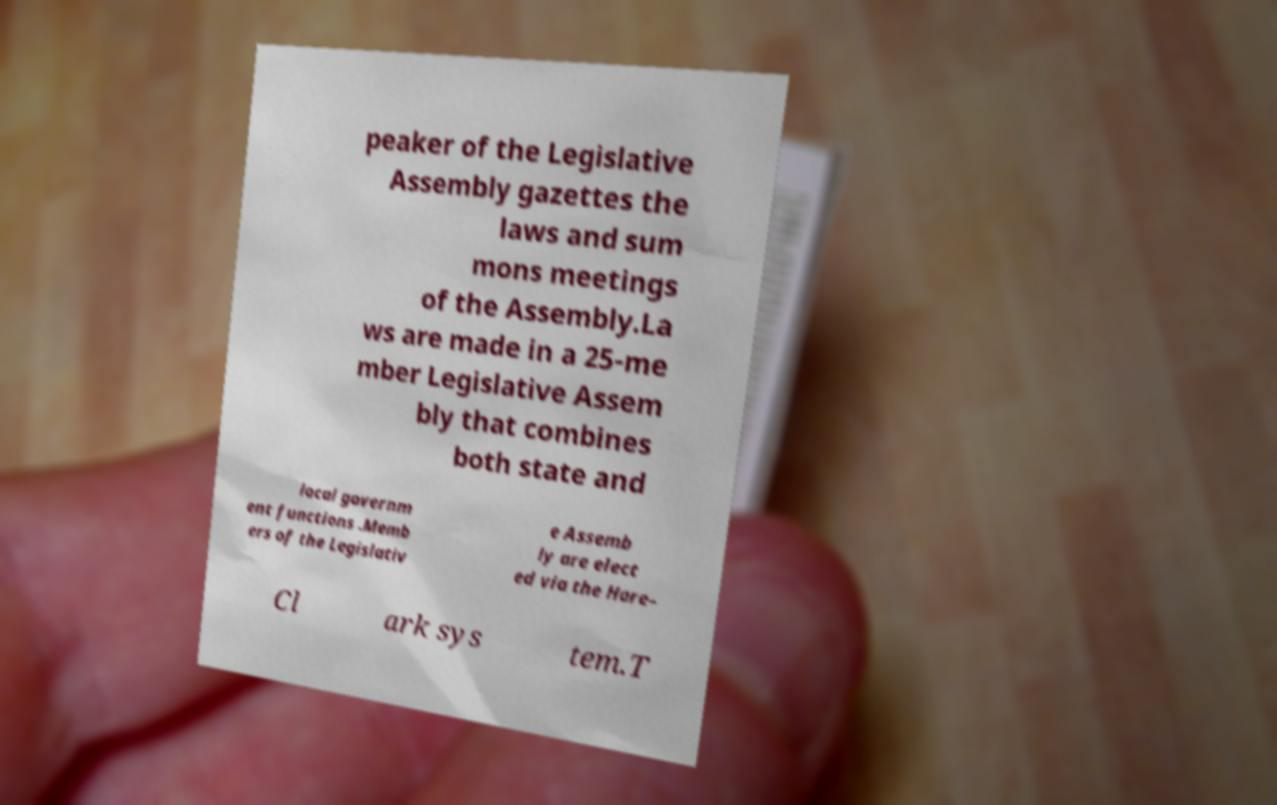There's text embedded in this image that I need extracted. Can you transcribe it verbatim? peaker of the Legislative Assembly gazettes the laws and sum mons meetings of the Assembly.La ws are made in a 25-me mber Legislative Assem bly that combines both state and local governm ent functions .Memb ers of the Legislativ e Assemb ly are elect ed via the Hare– Cl ark sys tem.T 